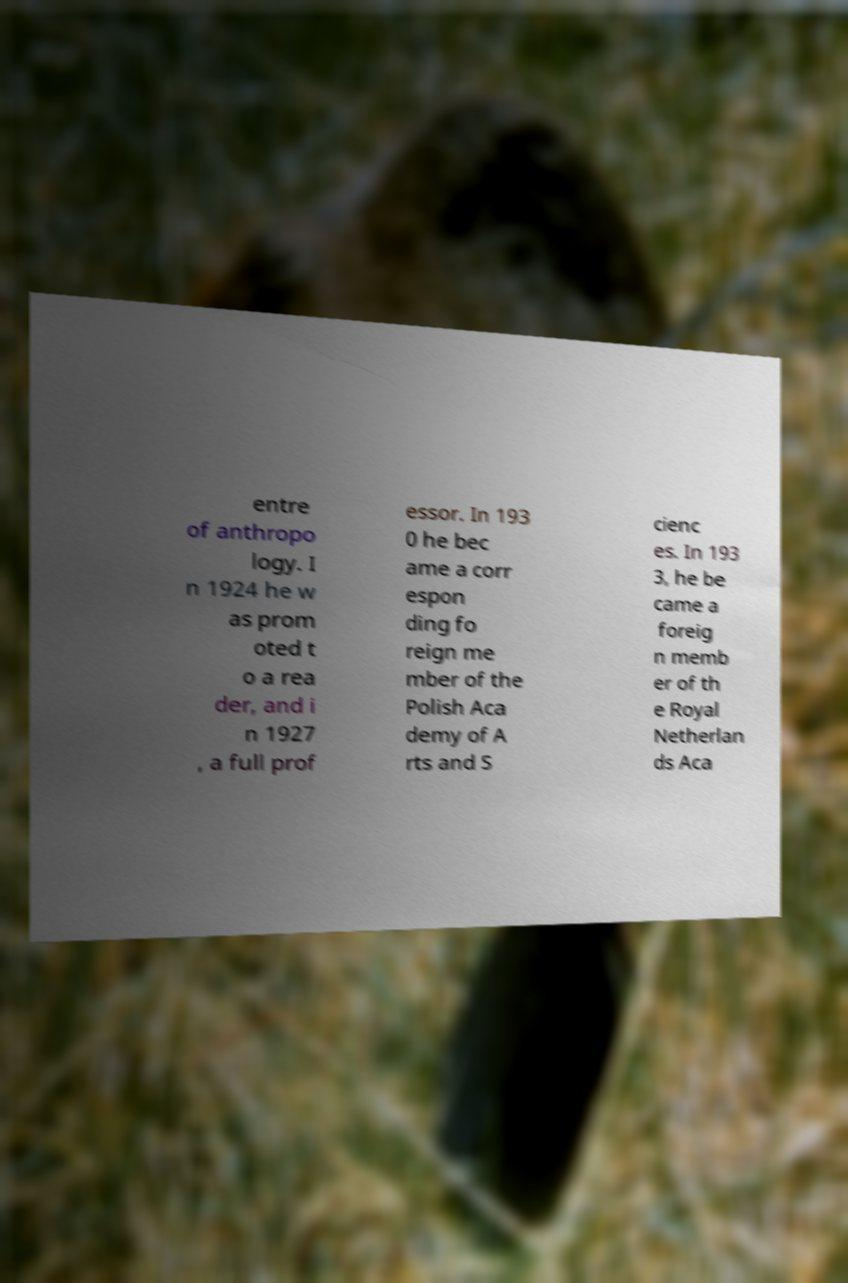For documentation purposes, I need the text within this image transcribed. Could you provide that? entre of anthropo logy. I n 1924 he w as prom oted t o a rea der, and i n 1927 , a full prof essor. In 193 0 he bec ame a corr espon ding fo reign me mber of the Polish Aca demy of A rts and S cienc es. In 193 3, he be came a foreig n memb er of th e Royal Netherlan ds Aca 